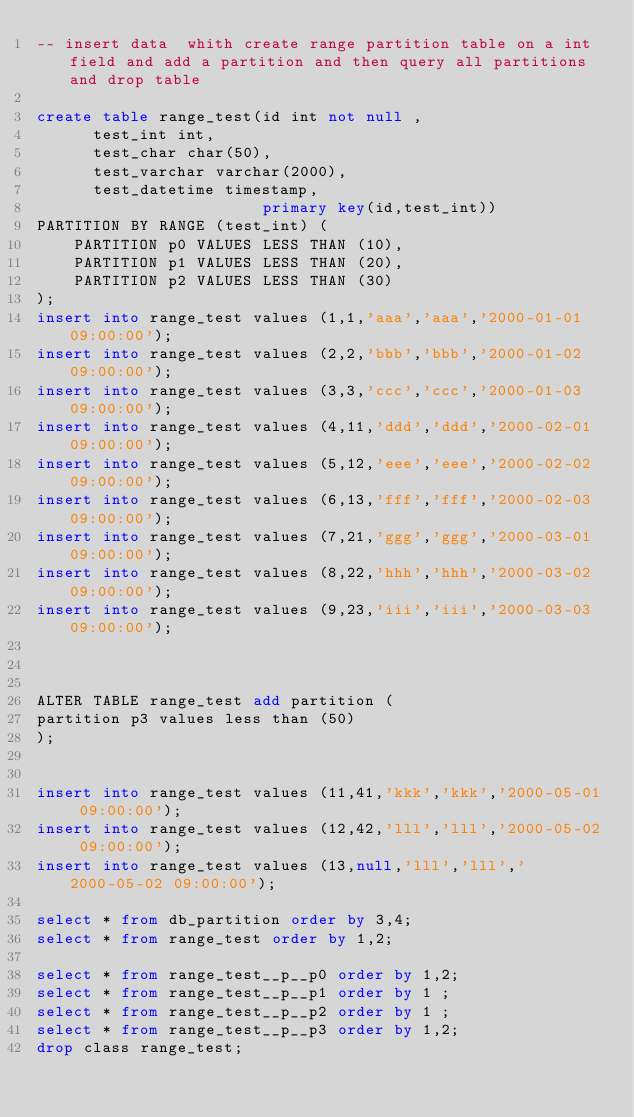<code> <loc_0><loc_0><loc_500><loc_500><_SQL_>-- insert data  whith create range partition table on a int field and add a partition and then query all partitions and drop table

create table range_test(id int not null ,
			test_int int,
			test_char char(50),
			test_varchar varchar(2000),
			test_datetime timestamp,
                        primary key(id,test_int))
PARTITION BY RANGE (test_int) (
    PARTITION p0 VALUES LESS THAN (10),
    PARTITION p1 VALUES LESS THAN (20),
    PARTITION p2 VALUES LESS THAN (30)
);
insert into range_test values (1,1,'aaa','aaa','2000-01-01 09:00:00');
insert into range_test values (2,2,'bbb','bbb','2000-01-02 09:00:00');
insert into range_test values (3,3,'ccc','ccc','2000-01-03 09:00:00');
insert into range_test values (4,11,'ddd','ddd','2000-02-01 09:00:00');
insert into range_test values (5,12,'eee','eee','2000-02-02 09:00:00');
insert into range_test values (6,13,'fff','fff','2000-02-03 09:00:00');
insert into range_test values (7,21,'ggg','ggg','2000-03-01 09:00:00');
insert into range_test values (8,22,'hhh','hhh','2000-03-02 09:00:00');
insert into range_test values (9,23,'iii','iii','2000-03-03 09:00:00');



ALTER TABLE range_test add partition (
partition p3 values less than (50)
);


insert into range_test values (11,41,'kkk','kkk','2000-05-01 09:00:00');
insert into range_test values (12,42,'lll','lll','2000-05-02 09:00:00');
insert into range_test values (13,null,'lll','lll','2000-05-02 09:00:00');

select * from db_partition order by 3,4;
select * from range_test order by 1,2;

select * from range_test__p__p0 order by 1,2;
select * from range_test__p__p1 order by 1 ;
select * from range_test__p__p2 order by 1 ;
select * from range_test__p__p3 order by 1,2;
drop class range_test;
</code> 